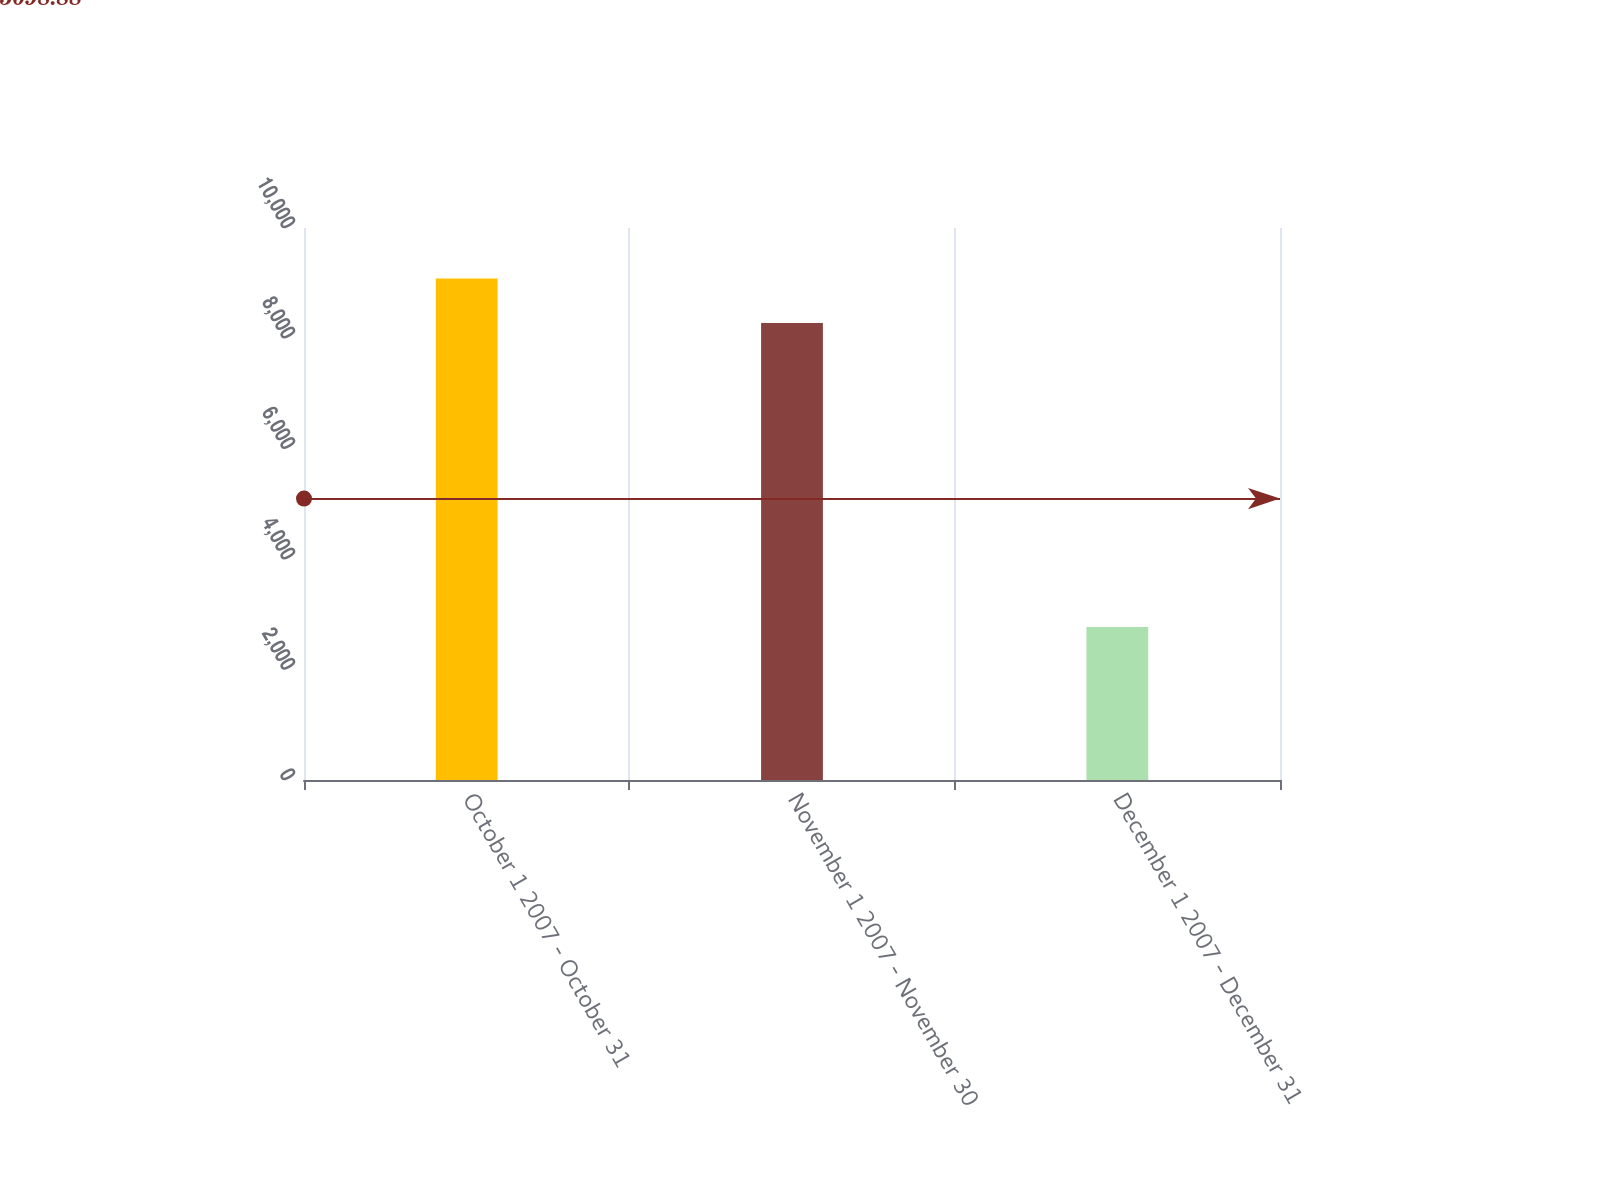<chart> <loc_0><loc_0><loc_500><loc_500><bar_chart><fcel>October 1 2007 - October 31<fcel>November 1 2007 - November 30<fcel>December 1 2007 - December 31<nl><fcel>9086<fcel>8280<fcel>2773<nl></chart> 